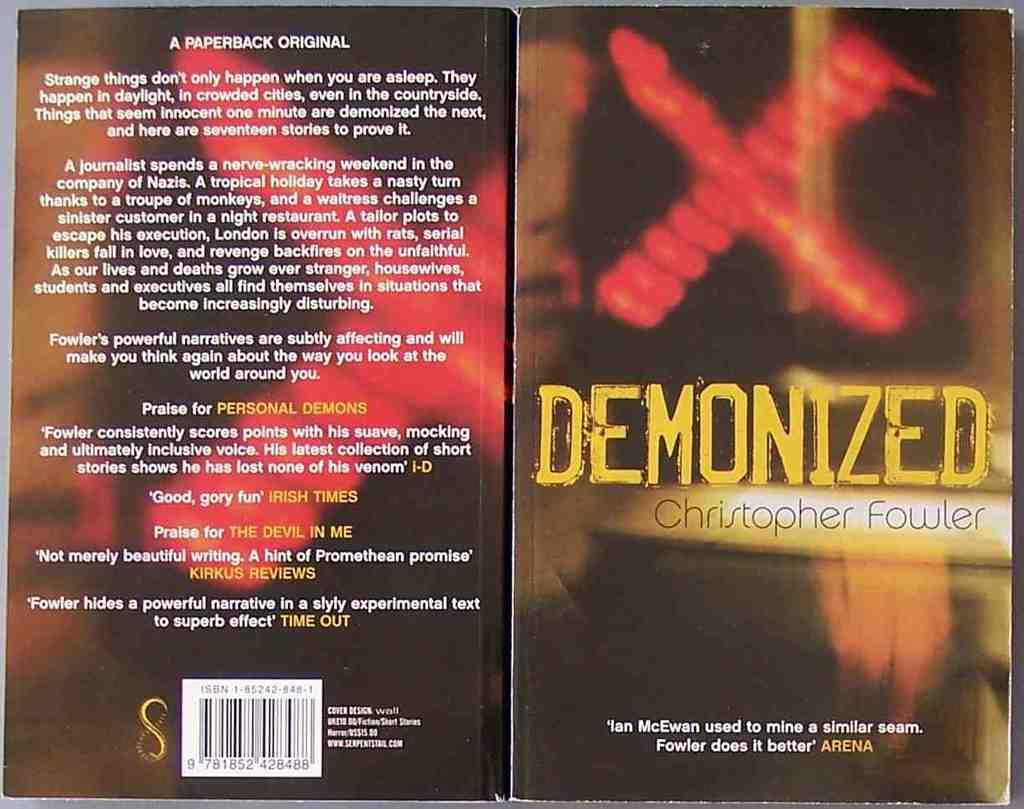<image>
Create a compact narrative representing the image presented. A book by Christopher Fowler with a red X cover design is titled Demonized. 